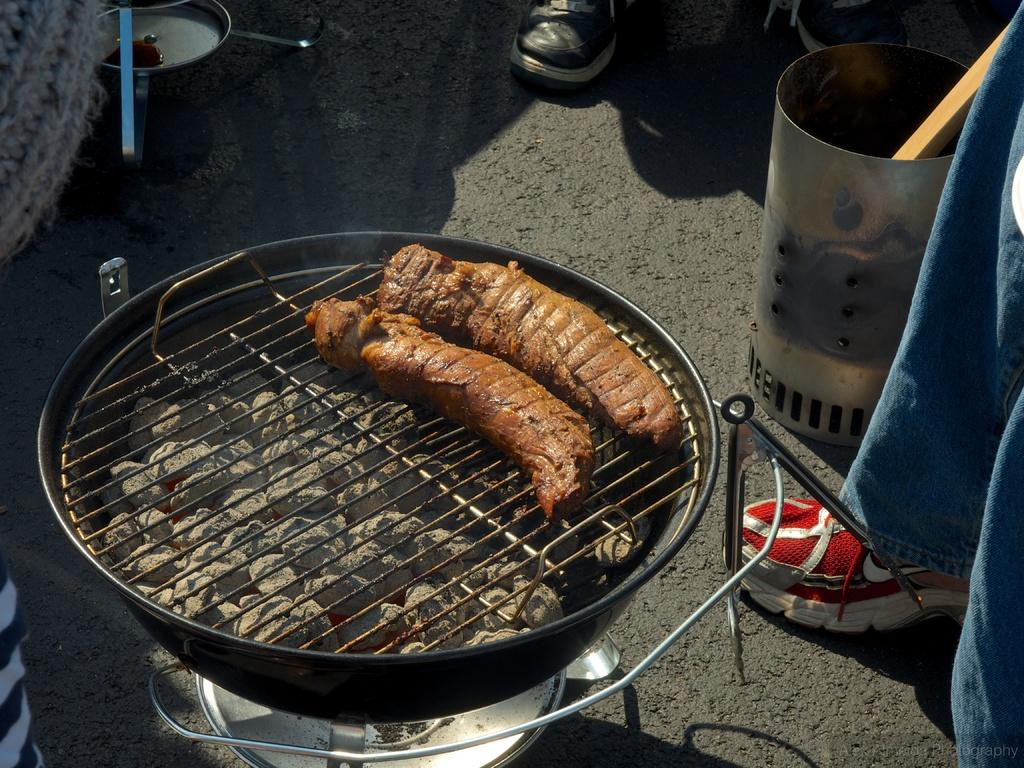What is being cooked on the grill stove in the image? There is food on a grill stove in the image. What is the color of the food being cooked? The food is brown in color. What can be seen in the background of the image? There are objects and people visible in the background of the image. Is there a frame around the food on the grill stove in the image? There is no frame visible around the food on the grill stove in the image. Can you see a faucet in the image? There is no faucet present in the image. 